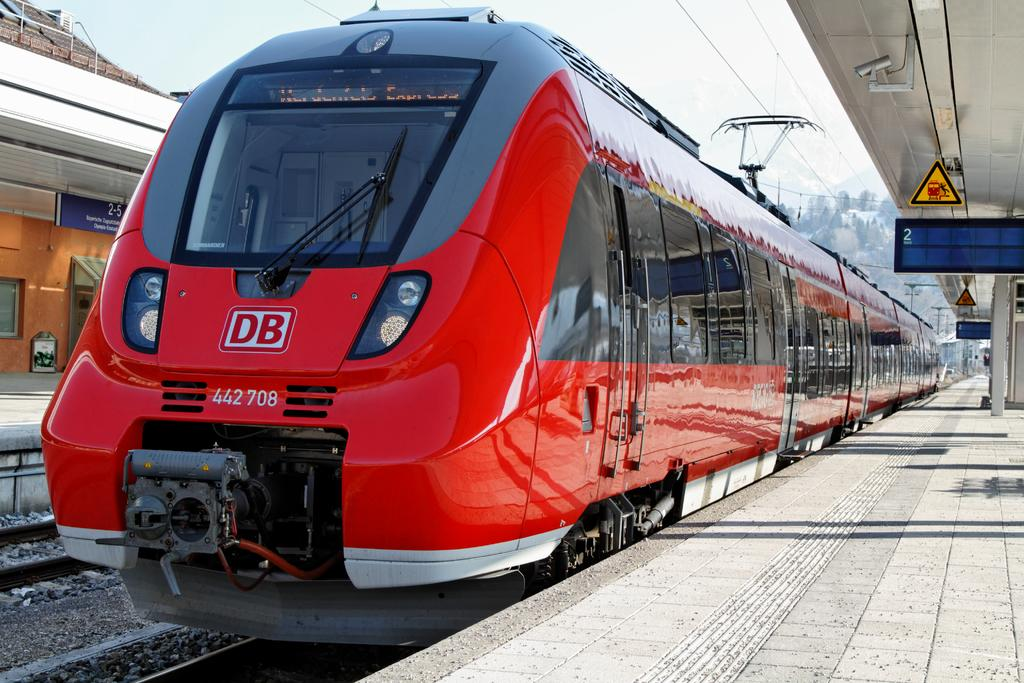Provide a one-sentence caption for the provided image. A DB train is waiting at the station. 